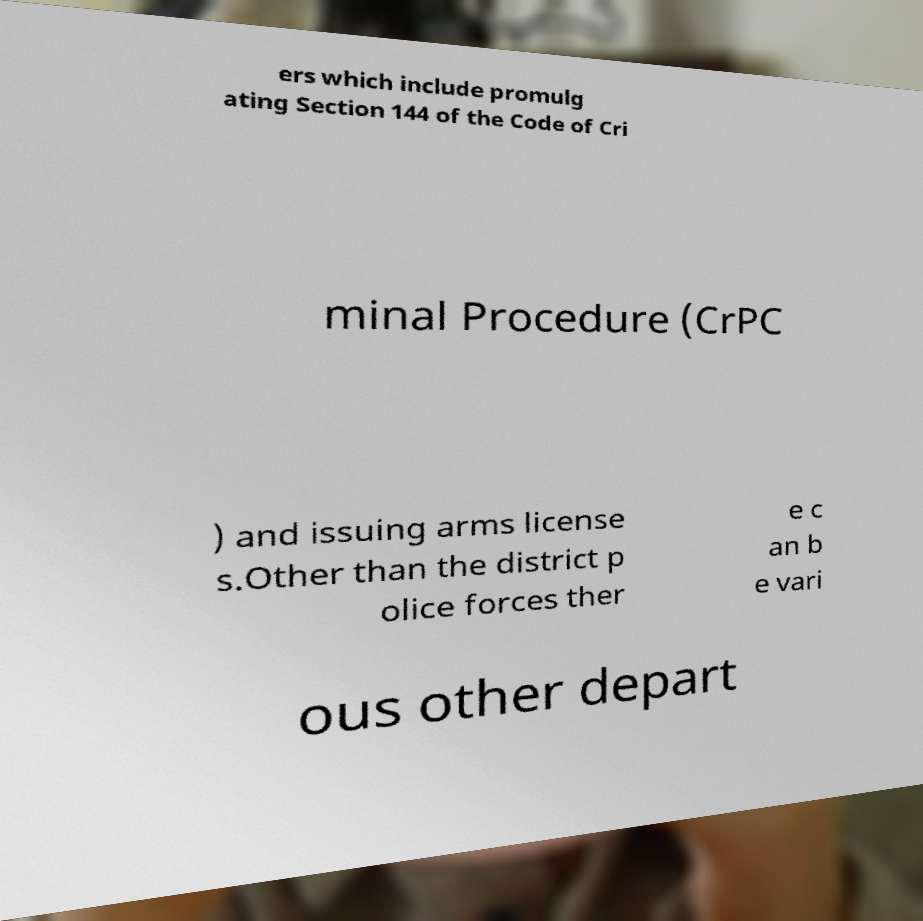Can you accurately transcribe the text from the provided image for me? ers which include promulg ating Section 144 of the Code of Cri minal Procedure (CrPC ) and issuing arms license s.Other than the district p olice forces ther e c an b e vari ous other depart 